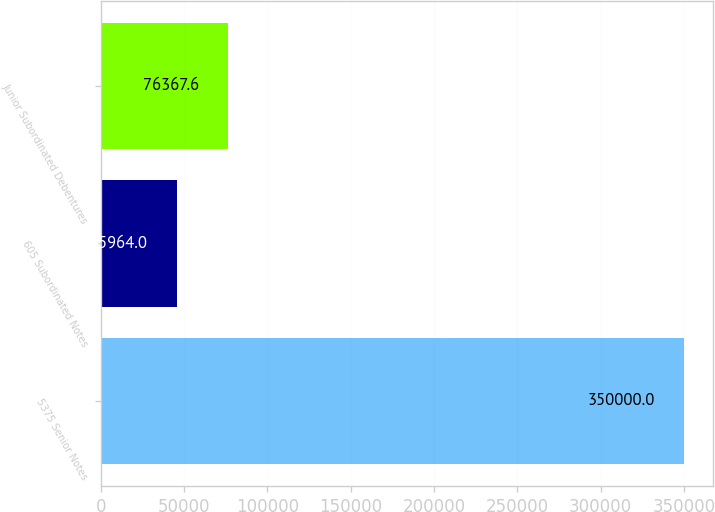<chart> <loc_0><loc_0><loc_500><loc_500><bar_chart><fcel>5375 Senior Notes<fcel>605 Subordinated Notes<fcel>Junior Subordinated Debentures<nl><fcel>350000<fcel>45964<fcel>76367.6<nl></chart> 